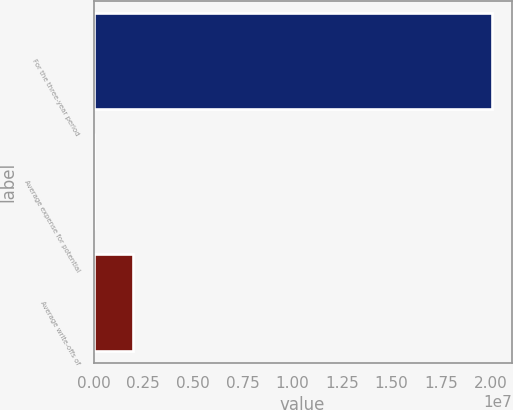Convert chart. <chart><loc_0><loc_0><loc_500><loc_500><bar_chart><fcel>For the three-year period<fcel>Average expense for potential<fcel>Average write-offs of<nl><fcel>2.0042e+07<fcel>0.8<fcel>2.0042e+06<nl></chart> 